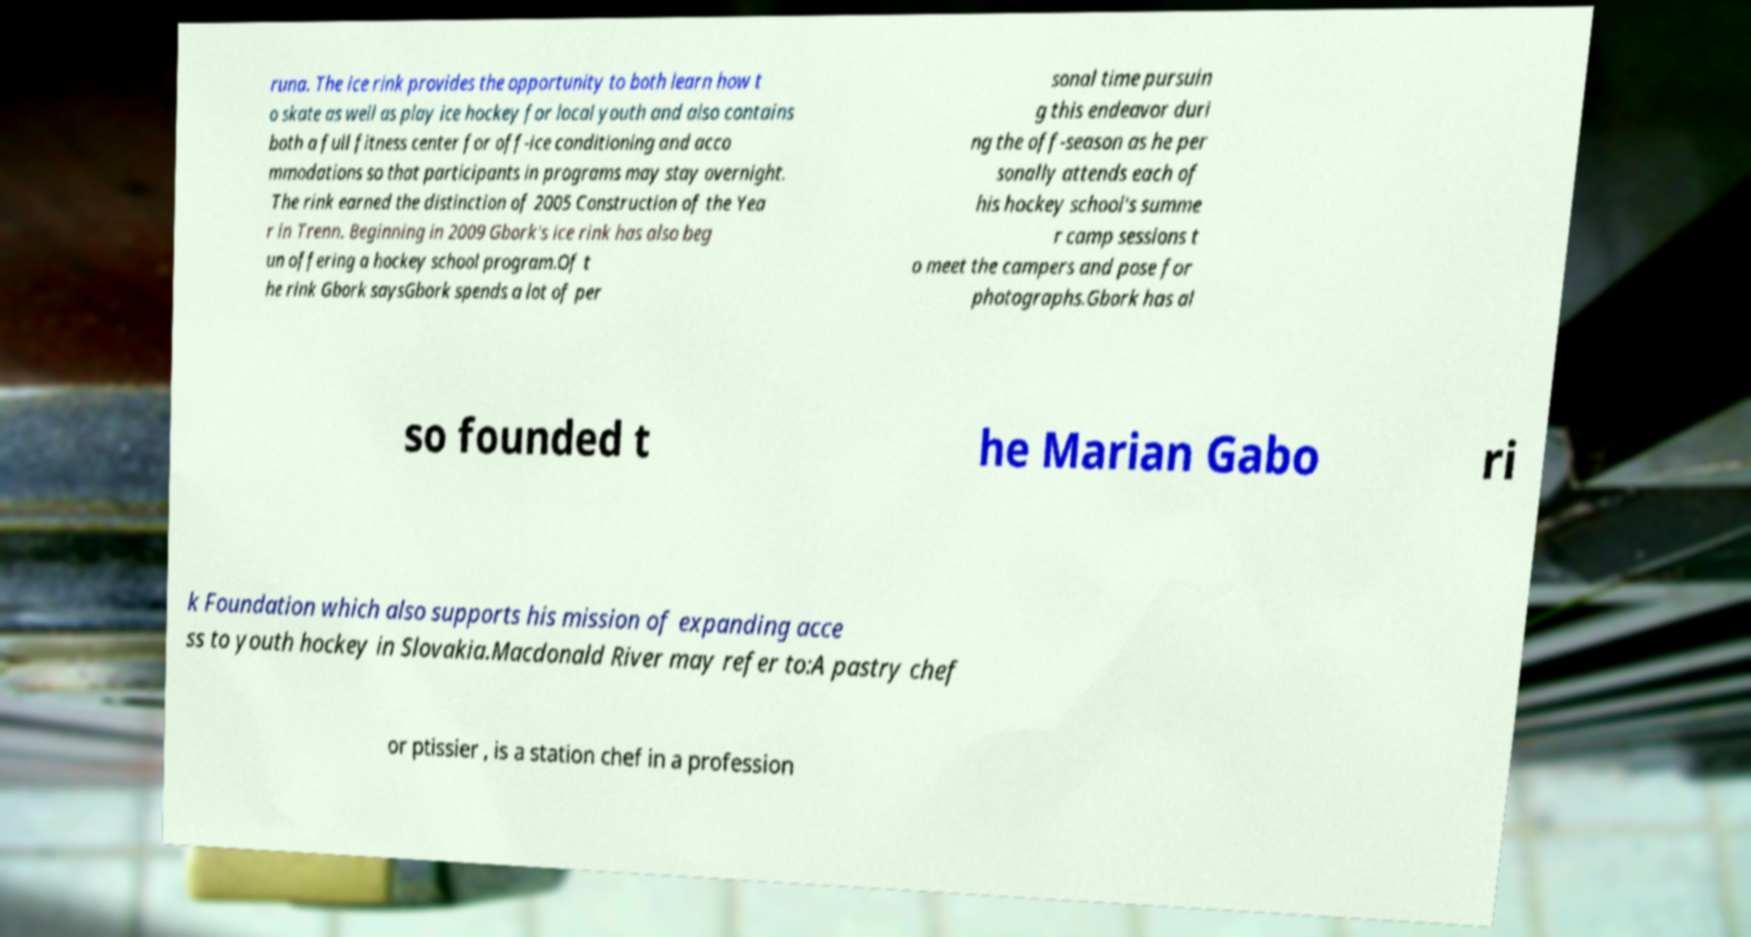Can you accurately transcribe the text from the provided image for me? runa. The ice rink provides the opportunity to both learn how t o skate as well as play ice hockey for local youth and also contains both a full fitness center for off-ice conditioning and acco mmodations so that participants in programs may stay overnight. The rink earned the distinction of 2005 Construction of the Yea r in Trenn. Beginning in 2009 Gbork's ice rink has also beg un offering a hockey school program.Of t he rink Gbork saysGbork spends a lot of per sonal time pursuin g this endeavor duri ng the off-season as he per sonally attends each of his hockey school's summe r camp sessions t o meet the campers and pose for photographs.Gbork has al so founded t he Marian Gabo ri k Foundation which also supports his mission of expanding acce ss to youth hockey in Slovakia.Macdonald River may refer to:A pastry chef or ptissier , is a station chef in a profession 